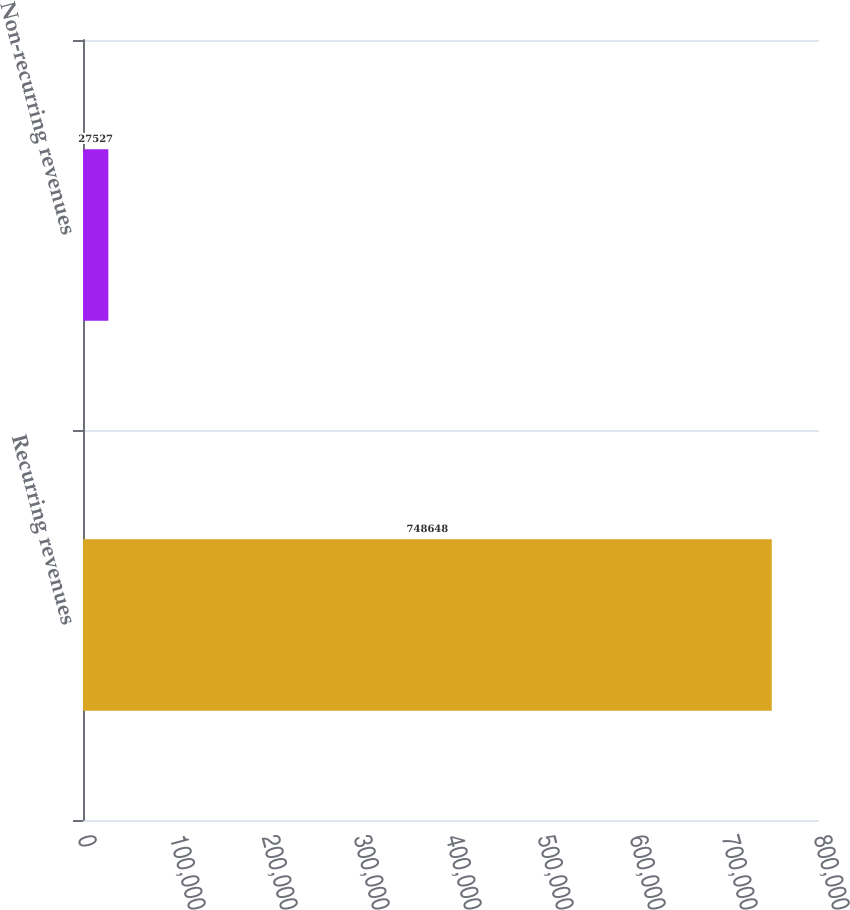Convert chart. <chart><loc_0><loc_0><loc_500><loc_500><bar_chart><fcel>Recurring revenues<fcel>Non-recurring revenues<nl><fcel>748648<fcel>27527<nl></chart> 